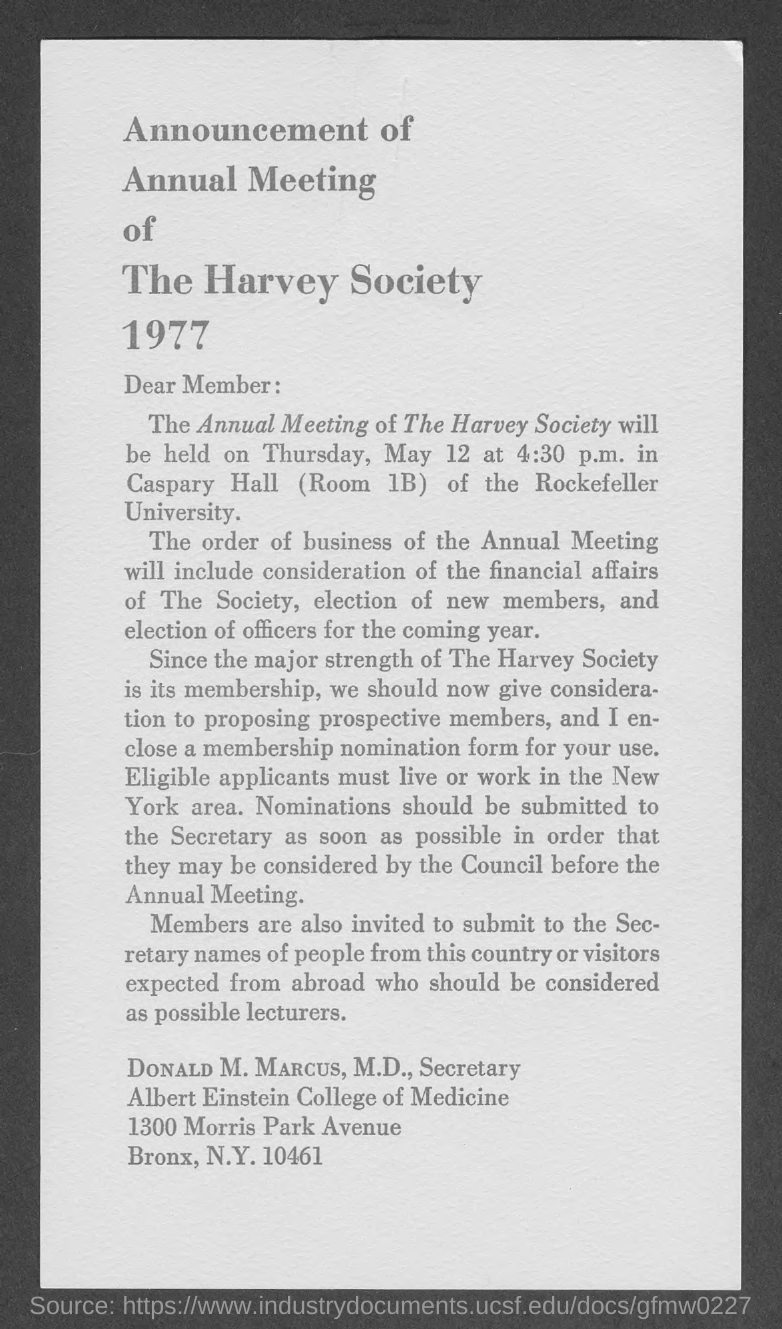Outline some significant characteristics in this image. The annual meeting is scheduled to commence at 4:30 p.m. The year mentioned is 1977. 